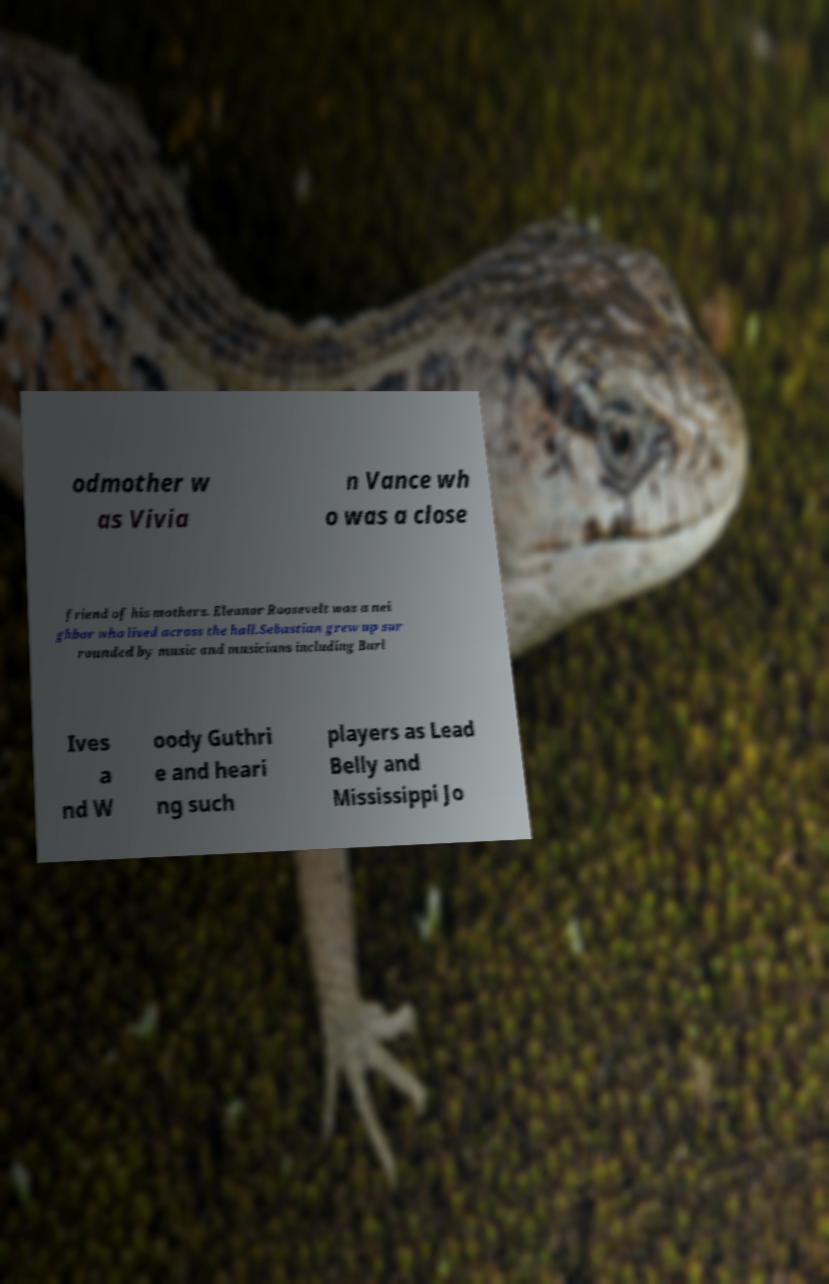Can you accurately transcribe the text from the provided image for me? odmother w as Vivia n Vance wh o was a close friend of his mothers. Eleanor Roosevelt was a nei ghbor who lived across the hall.Sebastian grew up sur rounded by music and musicians including Burl Ives a nd W oody Guthri e and heari ng such players as Lead Belly and Mississippi Jo 